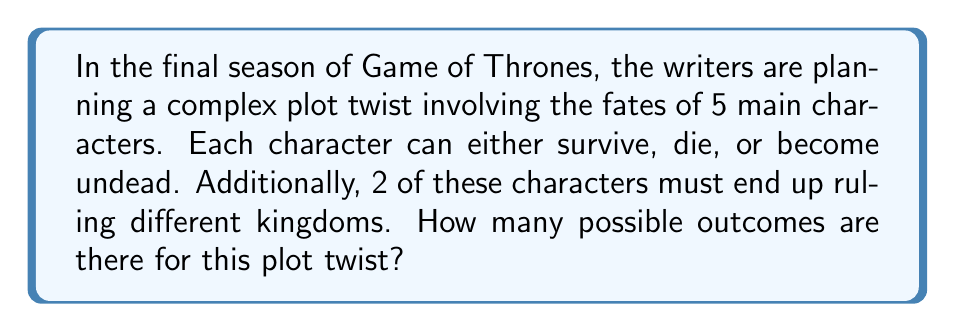Could you help me with this problem? Let's break this down step-by-step:

1) First, we need to consider the possible fates for each character:
   - Each character has 3 possible outcomes: survive, die, or become undead
   - We have 5 characters in total
   - This gives us $3^5 = 243$ possible combinations for the fates of all characters

2) Now, we need to consider the ruling factor:
   - 2 characters must end up ruling different kingdoms
   - These 2 characters must be from the group that survived
   - We need to calculate how many ways we can choose 2 rulers from the surviving characters

3) Let's consider the number of survivors:
   - We can have 2, 3, 4, or 5 survivors (we need at least 2 for the ruling condition)
   - For each of these cases, we need to calculate:
     a) The number of ways to choose the survivors
     b) The number of ways to choose 2 rulers from the survivors

4) Let's calculate for each case:

   Case 1: 2 survivors
   - Ways to choose 2 survivors: $\binom{5}{2} = 10$
   - Ways to choose 2 rulers from 2 survivors: $\binom{2}{2} = 1$
   - Total for this case: $10 \times 1 \times 3^3 = 270$

   Case 2: 3 survivors
   - Ways to choose 3 survivors: $\binom{5}{3} = 10$
   - Ways to choose 2 rulers from 3 survivors: $\binom{3}{2} = 3$
   - Total for this case: $10 \times 3 \times 3^2 = 270$

   Case 3: 4 survivors
   - Ways to choose 4 survivors: $\binom{5}{4} = 5$
   - Ways to choose 2 rulers from 4 survivors: $\binom{4}{2} = 6$
   - Total for this case: $5 \times 6 \times 3^1 = 90$

   Case 4: 5 survivors
   - Ways to choose 5 survivors: $\binom{5}{5} = 1$
   - Ways to choose 2 rulers from 5 survivors: $\binom{5}{2} = 10$
   - Total for this case: $1 \times 10 \times 3^0 = 10$

5) The total number of possible outcomes is the sum of all these cases:
   $270 + 270 + 90 + 10 = 640$

Therefore, there are 640 possible outcomes for this complex plot twist.
Answer: 640 